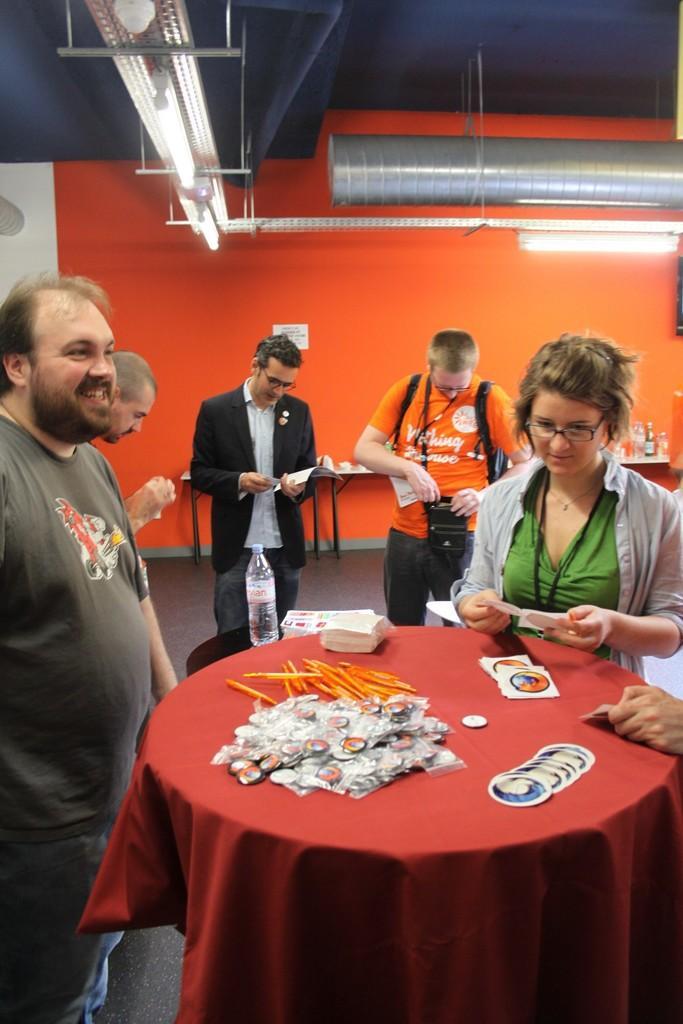Can you describe this image briefly? In this image, we can see few people. Few people are holding some objects. On the left side of the image, we can see a person is smiling. Here there is a table covered with cloth. Few things and objects are placed on it. Background we can see wall, poster, light, tables and few things. Top of the image, we can see lights, rods and pipe. 